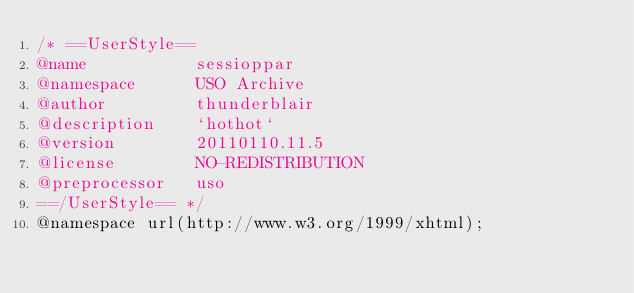Convert code to text. <code><loc_0><loc_0><loc_500><loc_500><_CSS_>/* ==UserStyle==
@name           sessioppar
@namespace      USO Archive
@author         thunderblair
@description    `hothot`
@version        20110110.11.5
@license        NO-REDISTRIBUTION
@preprocessor   uso
==/UserStyle== */
@namespace url(http://www.w3.org/1999/xhtml);






























</code> 